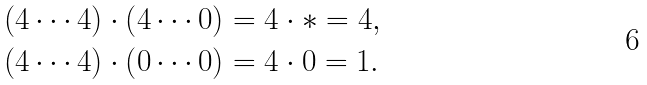<formula> <loc_0><loc_0><loc_500><loc_500>\left ( 4 \cdots 4 \right ) \cdot \left ( 4 \cdots 0 \right ) & = 4 \cdot \ast = 4 , \\ \left ( 4 \cdots 4 \right ) \cdot \left ( 0 \cdots 0 \right ) & = 4 \cdot 0 = 1 .</formula> 